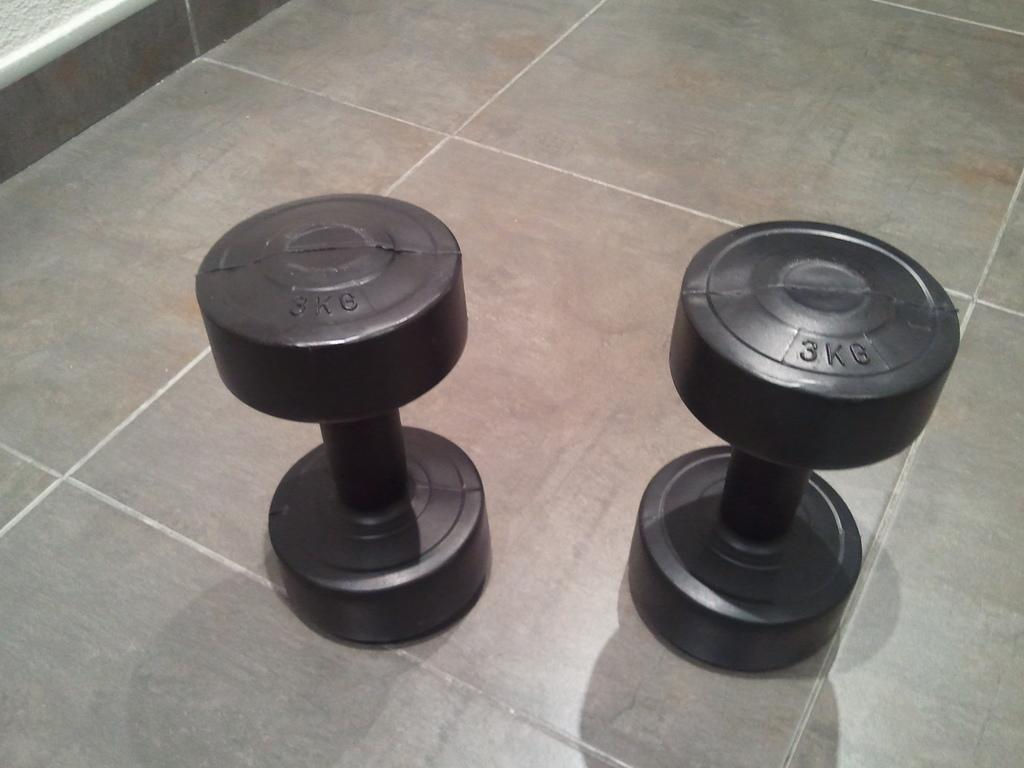What type of equipment is present in the image? There are two dumbbells in the image. What can be said about the color of the dumbbells? The dumbbells are black in color. What type of scent can be detected from the dumbbells in the image? There is no mention of a scent in the image, and the dumbbells are not associated with any scent. 